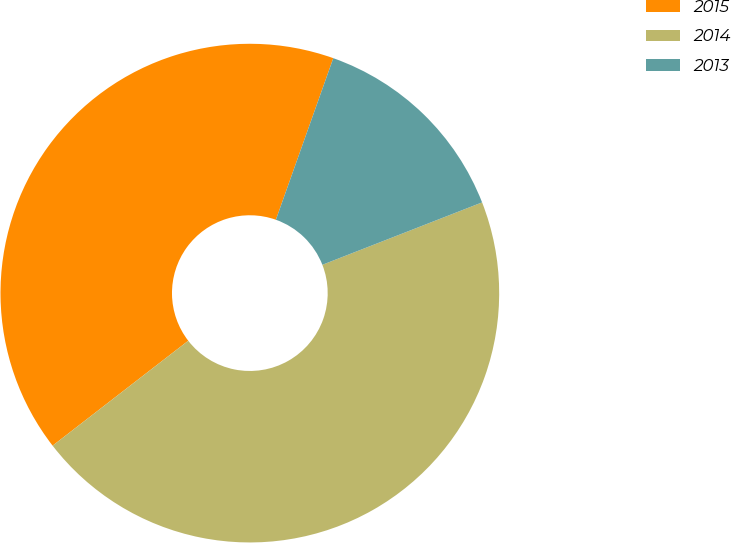<chart> <loc_0><loc_0><loc_500><loc_500><pie_chart><fcel>2015<fcel>2014<fcel>2013<nl><fcel>40.91%<fcel>45.45%<fcel>13.64%<nl></chart> 